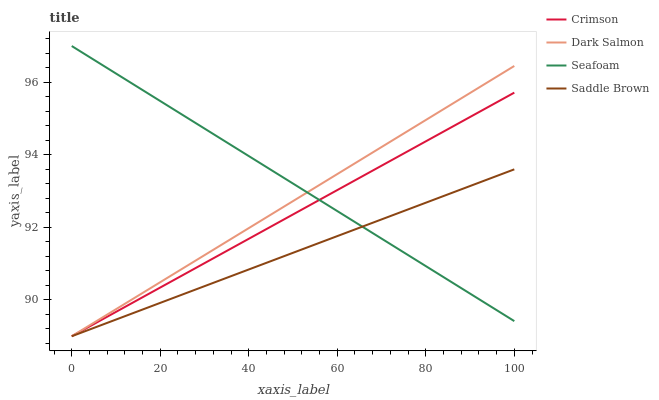Does Saddle Brown have the minimum area under the curve?
Answer yes or no. Yes. Does Seafoam have the maximum area under the curve?
Answer yes or no. Yes. Does Dark Salmon have the minimum area under the curve?
Answer yes or no. No. Does Dark Salmon have the maximum area under the curve?
Answer yes or no. No. Is Crimson the smoothest?
Answer yes or no. Yes. Is Dark Salmon the roughest?
Answer yes or no. Yes. Is Saddle Brown the smoothest?
Answer yes or no. No. Is Saddle Brown the roughest?
Answer yes or no. No. Does Crimson have the lowest value?
Answer yes or no. Yes. Does Seafoam have the lowest value?
Answer yes or no. No. Does Seafoam have the highest value?
Answer yes or no. Yes. Does Dark Salmon have the highest value?
Answer yes or no. No. Does Dark Salmon intersect Saddle Brown?
Answer yes or no. Yes. Is Dark Salmon less than Saddle Brown?
Answer yes or no. No. Is Dark Salmon greater than Saddle Brown?
Answer yes or no. No. 